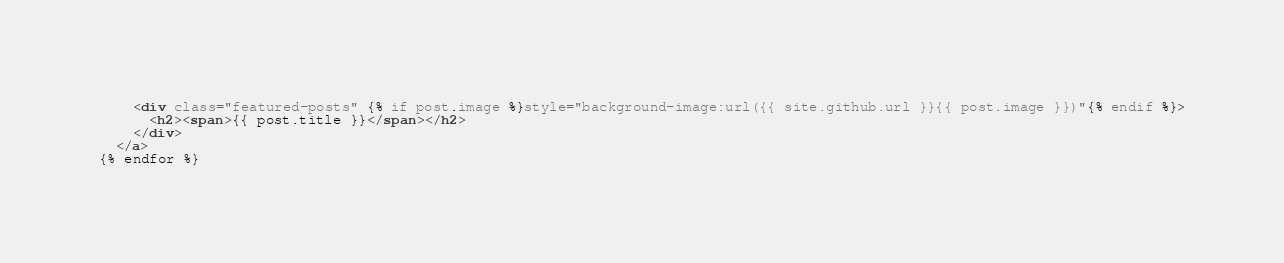<code> <loc_0><loc_0><loc_500><loc_500><_HTML_>    <div class="featured-posts" {% if post.image %}style="background-image:url({{ site.github.url }}{{ post.image }})"{% endif %}>
      <h2><span>{{ post.title }}</span></h2>
    </div>
  </a>
{% endfor %}
</code> 